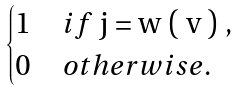Convert formula to latex. <formula><loc_0><loc_0><loc_500><loc_500>\begin{cases} 1 & i f $ j = w ( v ) $ , \\ 0 & o t h e r w i s e . \end{cases}</formula> 